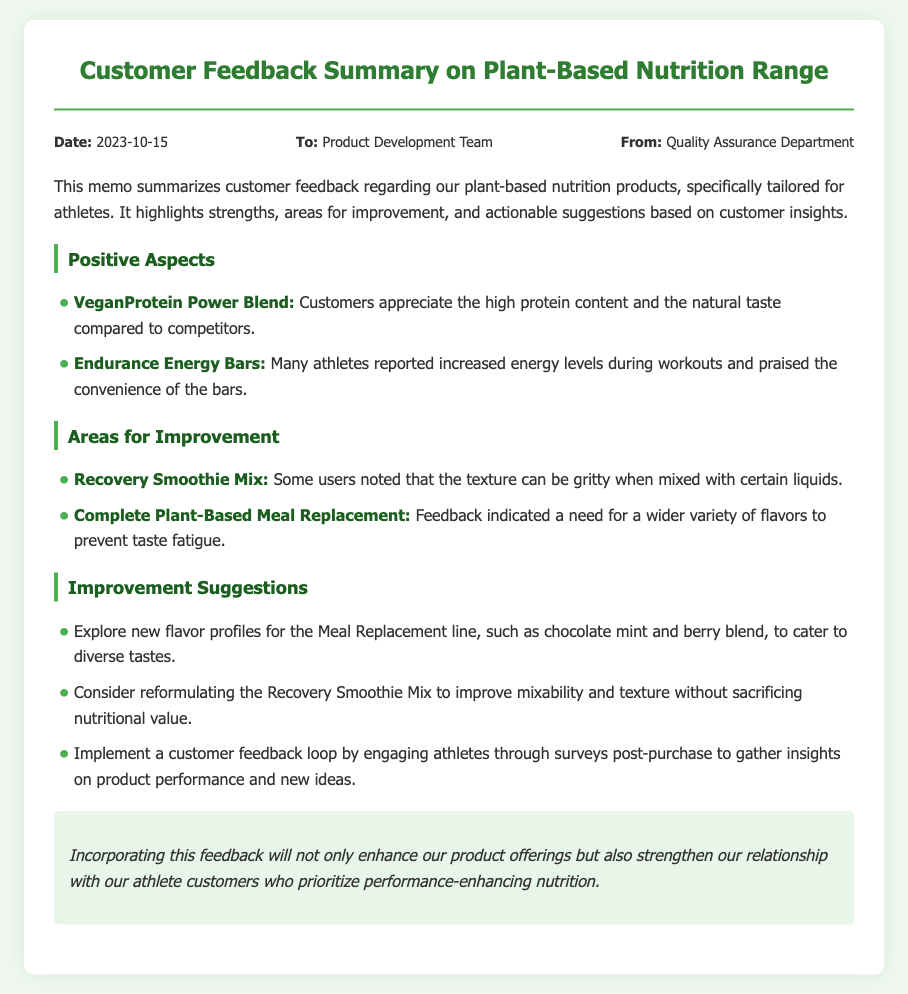What is the date of the memo? The date is specified in the memo details section, which states "Date: 2023-10-15."
Answer: 2023-10-15 Who is the memo addressed to? The memo includes the recipient's name, which is "Product Development Team."
Answer: Product Development Team What product do users find has a gritty texture? The issue of gritty texture is mentioned in relation to the "Recovery Smoothie Mix."
Answer: Recovery Smoothie Mix What is one suggested new flavor profile for the Meal Replacement line? The memo suggests exploring "chocolate mint" as a new flavor profile.
Answer: chocolate mint How many positive aspects are mentioned in the feedback? There are two positive aspects listed under the Positive Aspects section.
Answer: 2 What action is suggested to gather customer insights? The document suggests to "implement a customer feedback loop" for engagement.
Answer: implement a customer feedback loop Which product is noted for its high protein content? The "VeganProtein Power Blend" is recognized for its high protein content.
Answer: VeganProtein Power Blend What is one reason customers appreciate the Endurance Energy Bars? Customers reported "increased energy levels during workouts" as a reason for their appreciation.
Answer: increased energy levels during workouts What is the conclusion of the memo? The conclusion emphasizes that incorporating feedback enhances products and strengthens relationships with customers.
Answer: Incorporating this feedback will not only enhance our product offerings but also strengthen our relationship with our athlete customers who prioritize performance-enhancing nutrition 